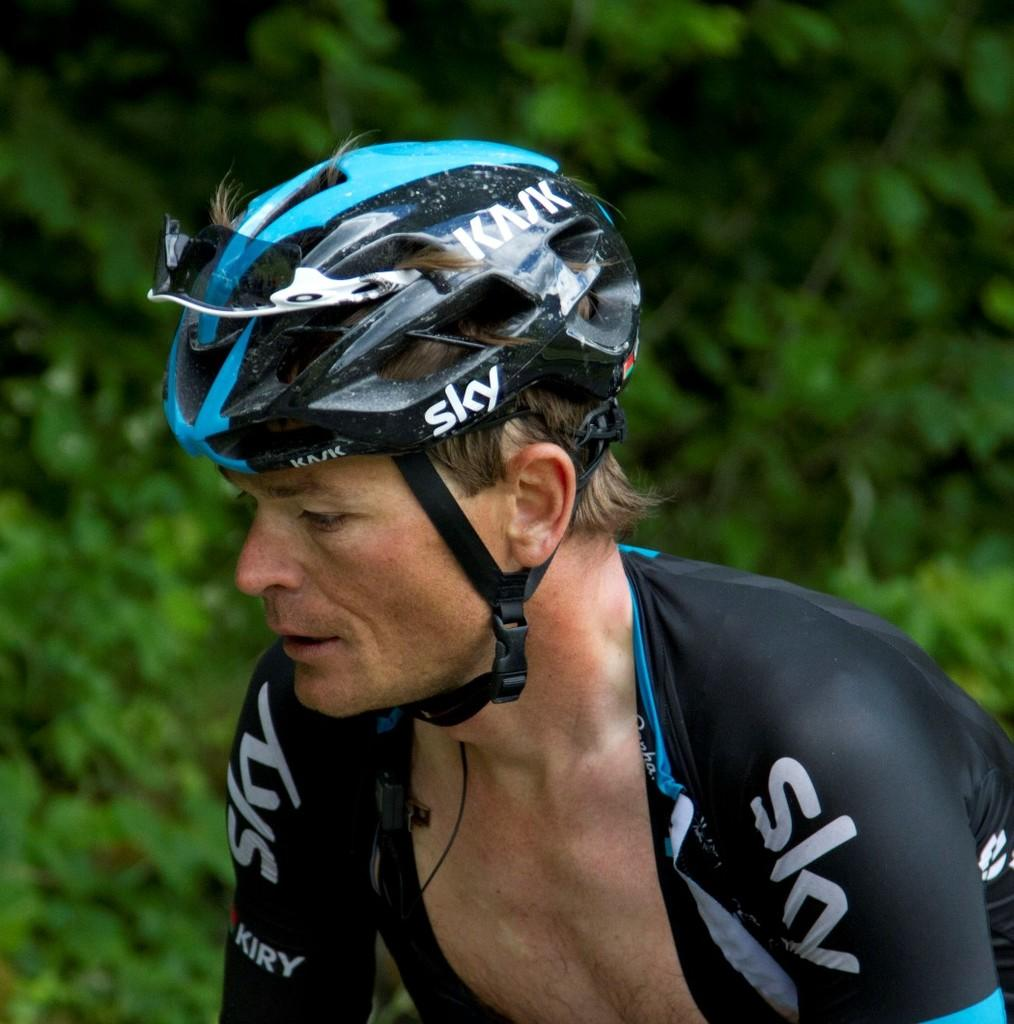What can be seen in the image? There is a person in the image. What is the person wearing? The person is wearing a helmet. Can you describe the background of the image? The background is green and blurred. What type of paste is being used by the person in the image? There is no paste visible in the image, and the person is not shown using any paste. 